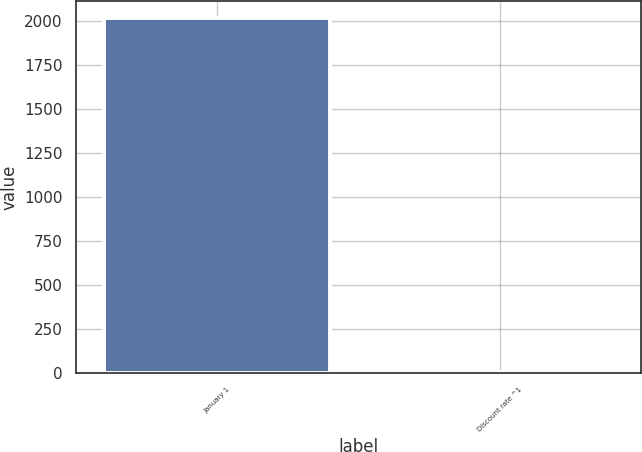Convert chart. <chart><loc_0><loc_0><loc_500><loc_500><bar_chart><fcel>January 1<fcel>Discount rate ^1<nl><fcel>2014<fcel>5<nl></chart> 